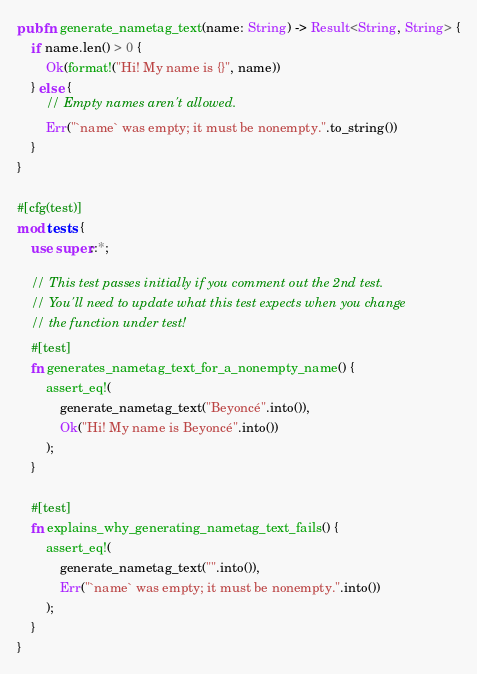Convert code to text. <code><loc_0><loc_0><loc_500><loc_500><_Rust_>


pub fn generate_nametag_text(name: String) -> Result<String, String> {
    if name.len() > 0 {
        Ok(format!("Hi! My name is {}", name))
    } else {
        // Empty names aren't allowed.
        Err("`name` was empty; it must be nonempty.".to_string())
    }
}

#[cfg(test)]
mod tests {
    use super::*;

    // This test passes initially if you comment out the 2nd test.
    // You'll need to update what this test expects when you change
    // the function under test!
    #[test]
    fn generates_nametag_text_for_a_nonempty_name() {
        assert_eq!(
            generate_nametag_text("Beyoncé".into()),
            Ok("Hi! My name is Beyoncé".into())
        );
    }

    #[test]
    fn explains_why_generating_nametag_text_fails() {
        assert_eq!(
            generate_nametag_text("".into()),
            Err("`name` was empty; it must be nonempty.".into())
        );
    }
}
</code> 